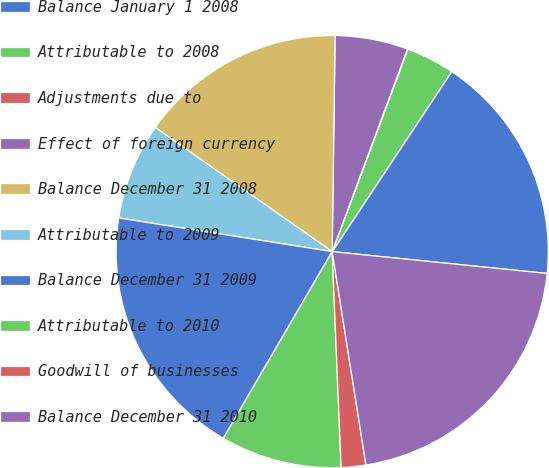Convert chart. <chart><loc_0><loc_0><loc_500><loc_500><pie_chart><fcel>Balance January 1 2008<fcel>Attributable to 2008<fcel>Adjustments due to<fcel>Effect of foreign currency<fcel>Balance December 31 2008<fcel>Attributable to 2009<fcel>Balance December 31 2009<fcel>Attributable to 2010<fcel>Goodwill of businesses<fcel>Balance December 31 2010<nl><fcel>17.28%<fcel>3.64%<fcel>0.03%<fcel>5.45%<fcel>15.48%<fcel>7.25%<fcel>19.09%<fcel>9.06%<fcel>1.84%<fcel>20.89%<nl></chart> 